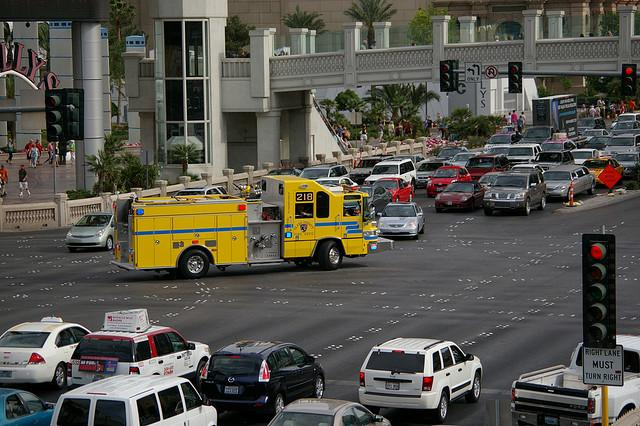Why are all the other cars letting the yellow truck go? Please explain your reasoning. emergency. The truck in the intersection is responding to an emergency. 